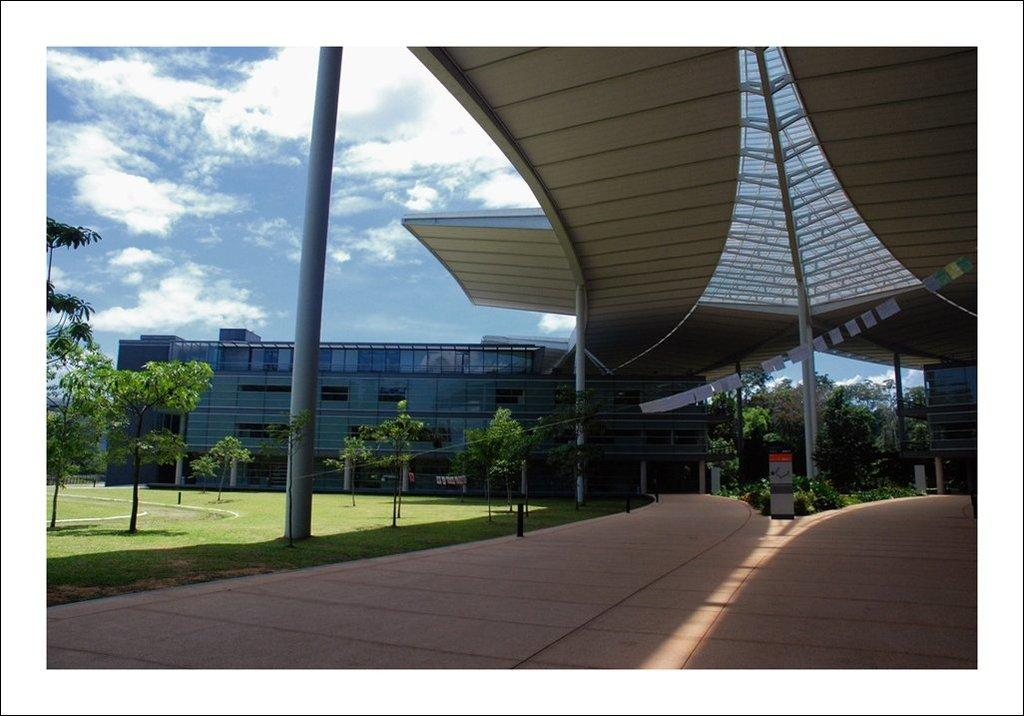What type of structure is visible in the image? There is a building in the image. What is on top of the building? There is a roof visible in the image. What other objects can be seen in the image? There are poles, trees, a board, and grass visible in the image. What is the condition of the sky in the image? The sky is cloudy in the image. What is the ground surface like in the image? There is ground visible in the image, and it appears to be covered with grass. What type of stage is set up for the religious ceremony in the image? There is no stage or religious ceremony present in the image. What type of pet can be seen playing with the board in the image? There is no pet visible in the image; only the board and other objects are present. 